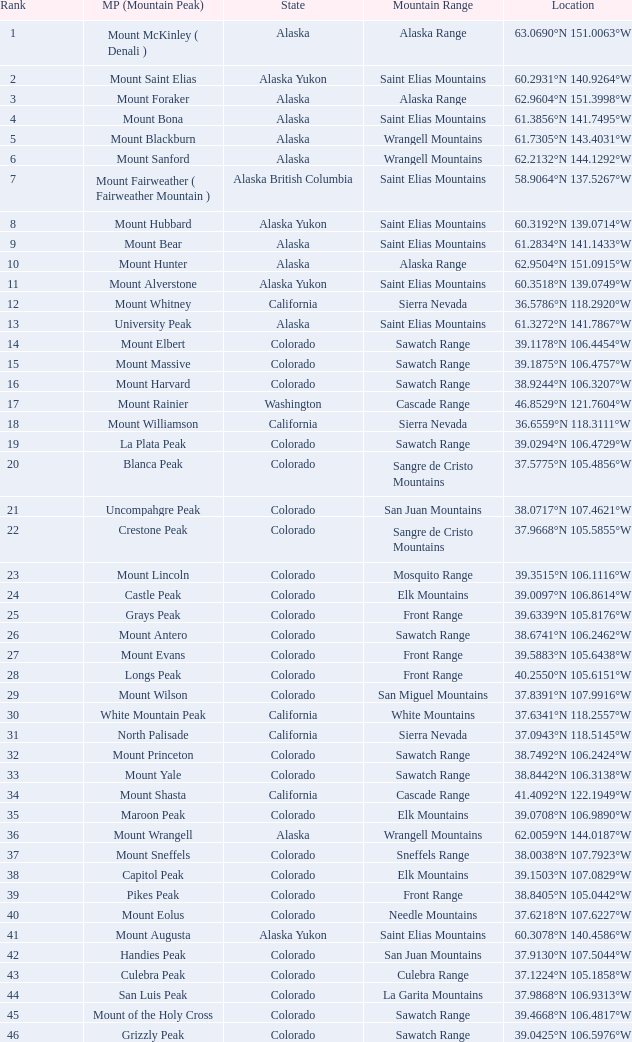What is the mountain range when the mountain peak is mauna kea? Island of Hawai ʻ i. 